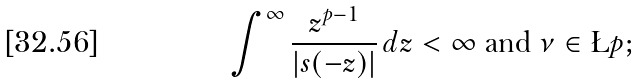Convert formula to latex. <formula><loc_0><loc_0><loc_500><loc_500>\int ^ { \infty } \frac { z ^ { p - 1 } } { | s ( - z ) | } \, d z < \infty \text { and } \nu \in \L p ;</formula> 